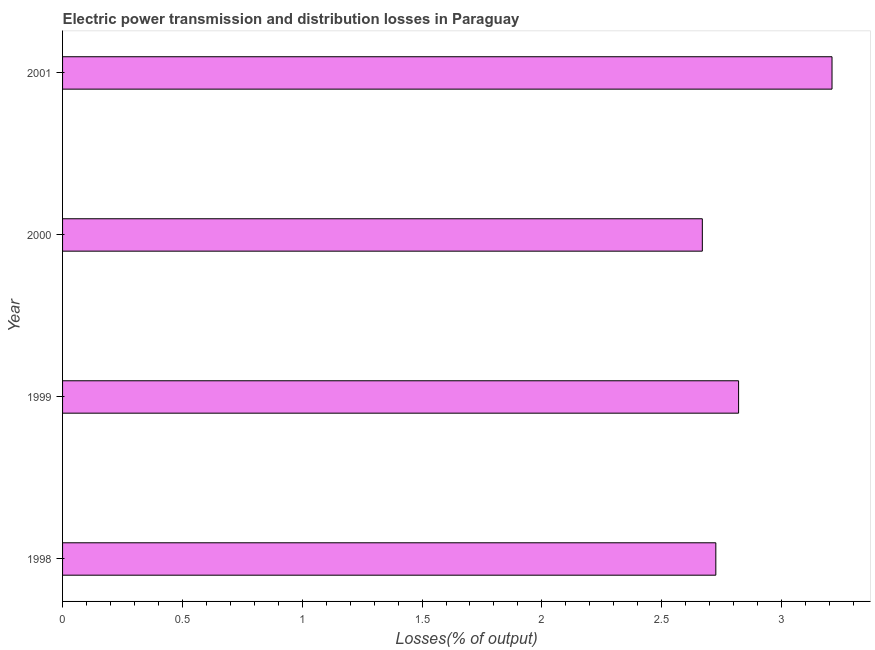What is the title of the graph?
Provide a succinct answer. Electric power transmission and distribution losses in Paraguay. What is the label or title of the X-axis?
Give a very brief answer. Losses(% of output). What is the label or title of the Y-axis?
Offer a terse response. Year. What is the electric power transmission and distribution losses in 2001?
Your answer should be very brief. 3.21. Across all years, what is the maximum electric power transmission and distribution losses?
Your response must be concise. 3.21. Across all years, what is the minimum electric power transmission and distribution losses?
Give a very brief answer. 2.67. In which year was the electric power transmission and distribution losses minimum?
Offer a terse response. 2000. What is the sum of the electric power transmission and distribution losses?
Ensure brevity in your answer.  11.43. What is the difference between the electric power transmission and distribution losses in 2000 and 2001?
Keep it short and to the point. -0.54. What is the average electric power transmission and distribution losses per year?
Offer a terse response. 2.86. What is the median electric power transmission and distribution losses?
Make the answer very short. 2.77. Is the electric power transmission and distribution losses in 1999 less than that in 2000?
Offer a very short reply. No. Is the difference between the electric power transmission and distribution losses in 1998 and 1999 greater than the difference between any two years?
Ensure brevity in your answer.  No. What is the difference between the highest and the second highest electric power transmission and distribution losses?
Give a very brief answer. 0.39. What is the difference between the highest and the lowest electric power transmission and distribution losses?
Your response must be concise. 0.54. In how many years, is the electric power transmission and distribution losses greater than the average electric power transmission and distribution losses taken over all years?
Ensure brevity in your answer.  1. Are the values on the major ticks of X-axis written in scientific E-notation?
Your response must be concise. No. What is the Losses(% of output) of 1998?
Keep it short and to the point. 2.73. What is the Losses(% of output) in 1999?
Provide a succinct answer. 2.82. What is the Losses(% of output) in 2000?
Provide a succinct answer. 2.67. What is the Losses(% of output) of 2001?
Ensure brevity in your answer.  3.21. What is the difference between the Losses(% of output) in 1998 and 1999?
Keep it short and to the point. -0.1. What is the difference between the Losses(% of output) in 1998 and 2000?
Your answer should be very brief. 0.06. What is the difference between the Losses(% of output) in 1998 and 2001?
Keep it short and to the point. -0.48. What is the difference between the Losses(% of output) in 1999 and 2000?
Provide a succinct answer. 0.15. What is the difference between the Losses(% of output) in 1999 and 2001?
Ensure brevity in your answer.  -0.39. What is the difference between the Losses(% of output) in 2000 and 2001?
Your response must be concise. -0.54. What is the ratio of the Losses(% of output) in 1998 to that in 2001?
Provide a succinct answer. 0.85. What is the ratio of the Losses(% of output) in 1999 to that in 2000?
Offer a very short reply. 1.06. What is the ratio of the Losses(% of output) in 1999 to that in 2001?
Keep it short and to the point. 0.88. What is the ratio of the Losses(% of output) in 2000 to that in 2001?
Offer a terse response. 0.83. 